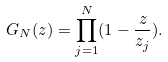<formula> <loc_0><loc_0><loc_500><loc_500>G _ { N } ( z ) = \prod _ { j = 1 } ^ { N } ( 1 - \frac { z } { z _ { j } } ) .</formula> 